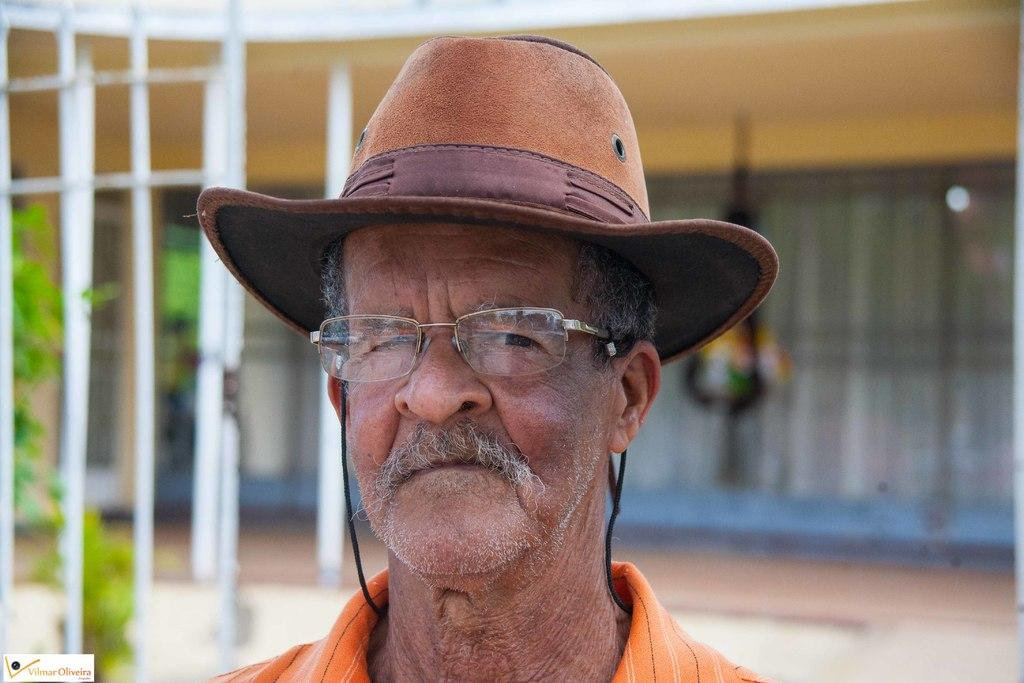Who is present in the image? There is a man in the image. What is the man wearing? The man is wearing clothes, spectacles, and a hat. What else can be seen in the image? There is a plant in the image. How would you describe the background of the image? The background of the image is blurred. What arithmetic problem is the man solving in the image? There is no arithmetic problem visible in the image. How many dolls are present in the image? There are no dolls present in the image. 